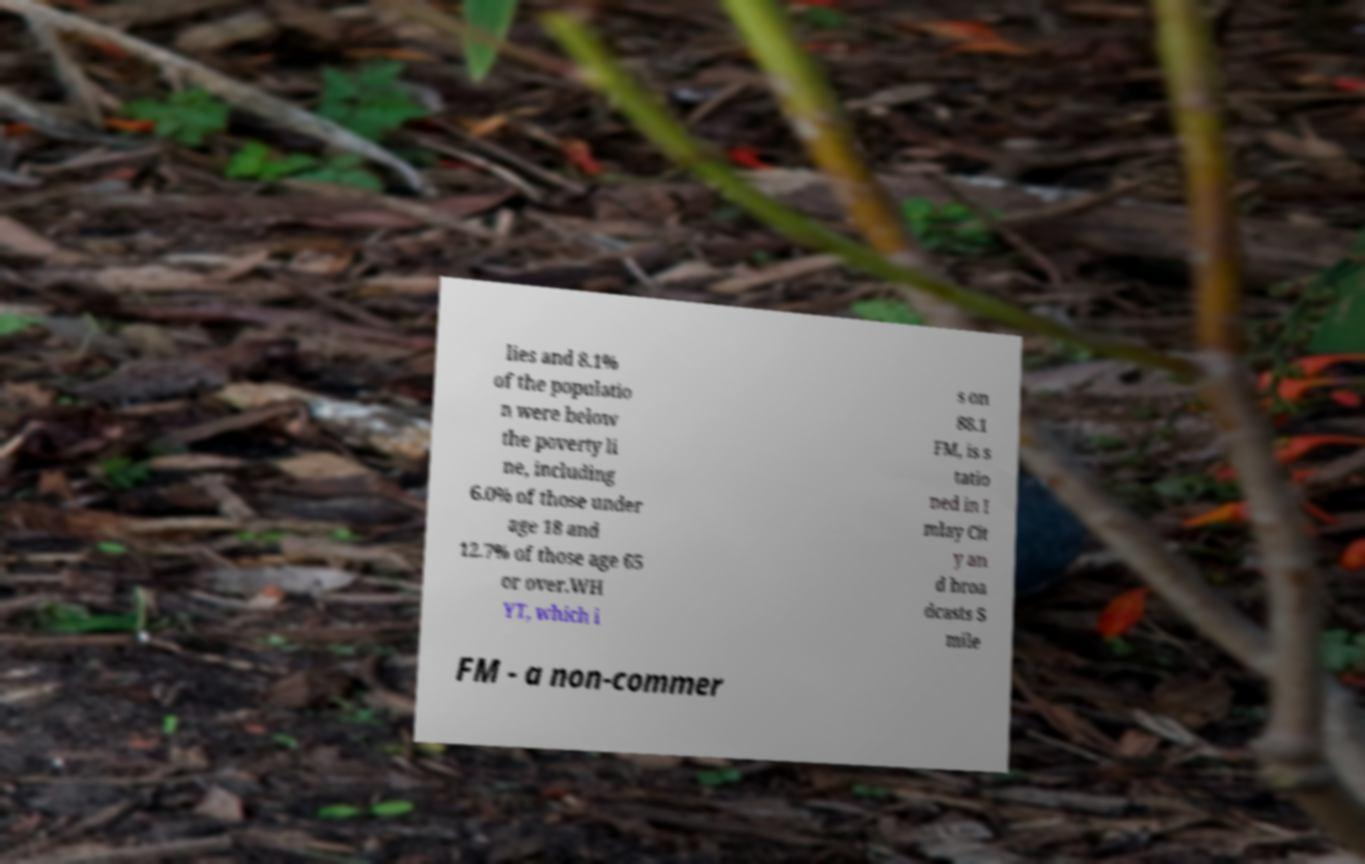Please identify and transcribe the text found in this image. lies and 8.1% of the populatio n were below the poverty li ne, including 6.0% of those under age 18 and 12.7% of those age 65 or over.WH YT, which i s on 88.1 FM, is s tatio ned in I mlay Cit y an d broa dcasts S mile FM - a non-commer 